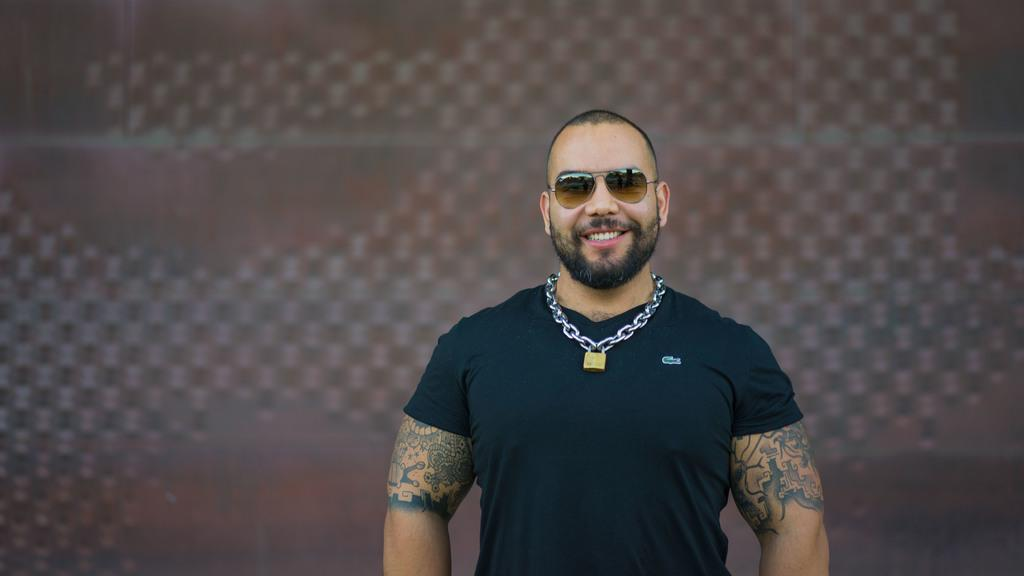What is the main subject of the image? There is a person in the image. What is the person wearing? The person is wearing a black dress. Are there any distinguishing features on the person's hands? Yes, the person has tattoos on their hands. What colors can be seen in the background of the image? The background of the image is in brown and white colors. Can you see any cactus plants in the image? There is no cactus plant present in the image. How many mice are visible in the image? There are no mice visible in the image. 